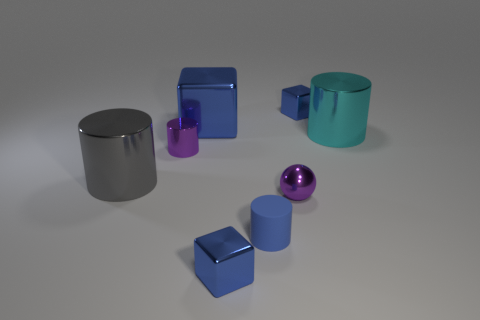How many tiny green metallic cylinders are there?
Your answer should be compact. 0. There is a large cylinder that is on the left side of the cube that is in front of the tiny blue rubber cylinder; what is its material?
Give a very brief answer. Metal. What is the material of the purple sphere that is the same size as the blue matte thing?
Your answer should be compact. Metal. Do the blue thing in front of the blue rubber cylinder and the purple sphere have the same size?
Give a very brief answer. Yes. Is the shape of the small shiny object that is in front of the matte thing the same as  the big gray object?
Provide a short and direct response. No. What number of objects are either large cubes or shiny objects that are right of the blue matte cylinder?
Provide a succinct answer. 4. Is the number of tiny purple spheres less than the number of purple objects?
Your response must be concise. Yes. Are there more blue cylinders than red shiny cylinders?
Keep it short and to the point. Yes. What number of other objects are the same material as the small purple cylinder?
Give a very brief answer. 6. How many small shiny objects are to the right of the blue cube on the right side of the tiny blue shiny cube in front of the small blue matte cylinder?
Provide a short and direct response. 0. 